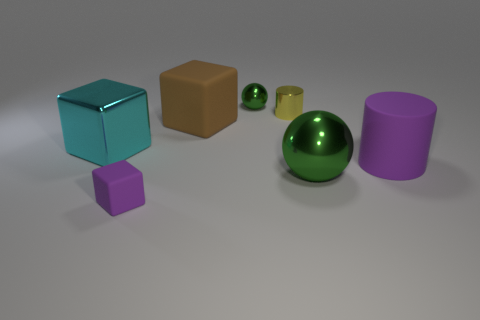Subtract all cyan cubes. How many cubes are left? 2 Subtract all big cubes. How many cubes are left? 1 Subtract all balls. How many objects are left? 5 Subtract 2 spheres. How many spheres are left? 0 Add 3 green metallic spheres. How many green metallic spheres are left? 5 Add 3 blocks. How many blocks exist? 6 Add 2 small yellow objects. How many objects exist? 9 Subtract 0 red blocks. How many objects are left? 7 Subtract all green cylinders. Subtract all purple balls. How many cylinders are left? 2 Subtract all blue balls. How many brown cubes are left? 1 